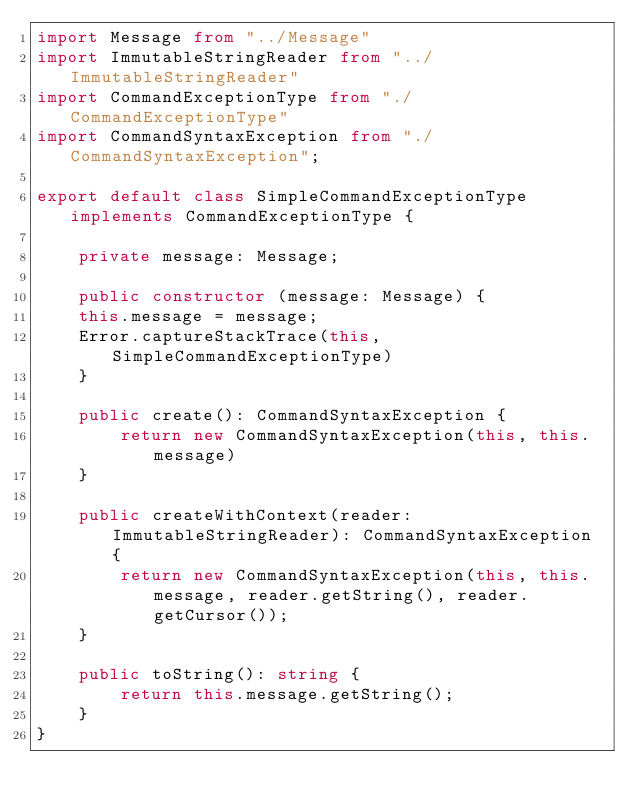Convert code to text. <code><loc_0><loc_0><loc_500><loc_500><_TypeScript_>import Message from "../Message"
import ImmutableStringReader from "../ImmutableStringReader"
import CommandExceptionType from "./CommandExceptionType"
import CommandSyntaxException from "./CommandSyntaxException";

export default class SimpleCommandExceptionType implements CommandExceptionType {

    private message: Message;

    public constructor (message: Message) {
		this.message = message;
		Error.captureStackTrace(this, SimpleCommandExceptionType)
    }

    public create(): CommandSyntaxException {
        return new CommandSyntaxException(this, this.message)
    }

    public createWithContext(reader: ImmutableStringReader): CommandSyntaxException {
        return new CommandSyntaxException(this, this.message, reader.getString(), reader.getCursor());
    }

    public toString(): string {
        return this.message.getString();
    }
}
</code> 